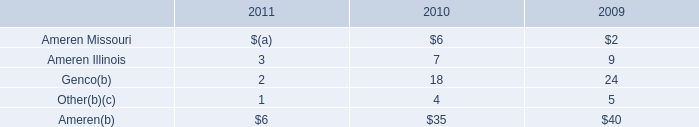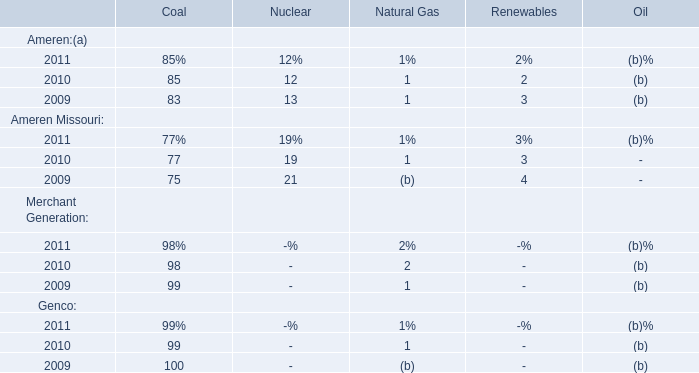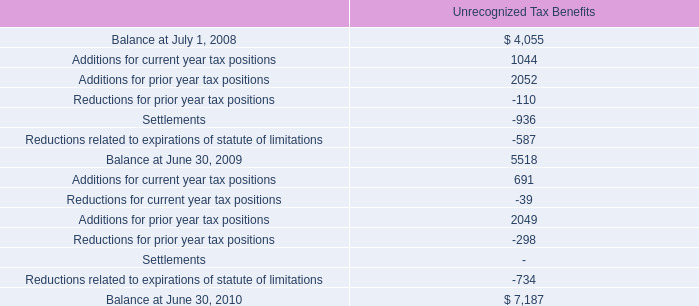if the companies accounting policy were to include accrued interest and penalties in utp , what would the balance be as of at june 30 2009? 
Computations: (5518 + 732)
Answer: 6250.0. 